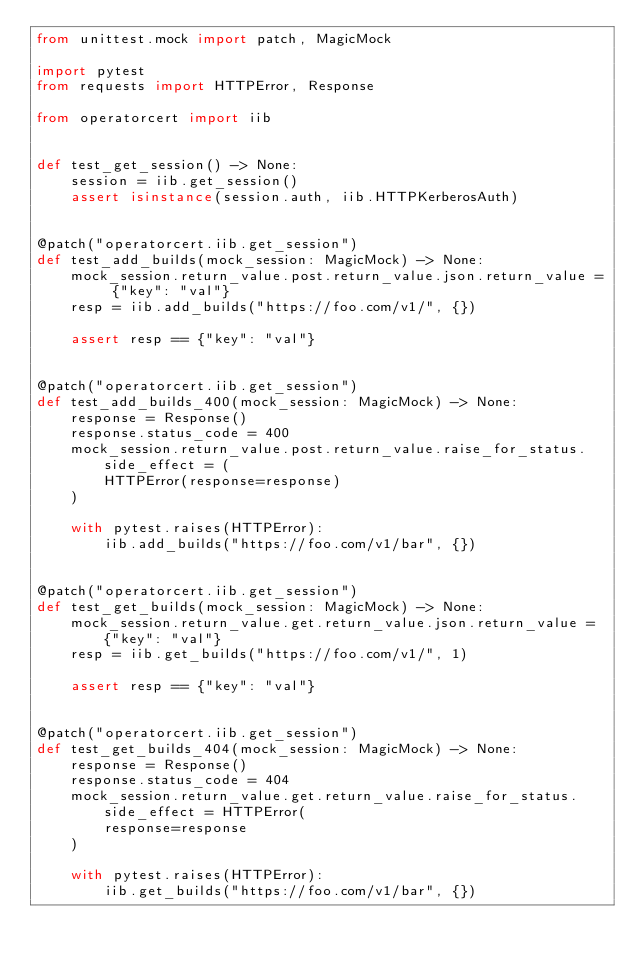<code> <loc_0><loc_0><loc_500><loc_500><_Python_>from unittest.mock import patch, MagicMock

import pytest
from requests import HTTPError, Response

from operatorcert import iib


def test_get_session() -> None:
    session = iib.get_session()
    assert isinstance(session.auth, iib.HTTPKerberosAuth)


@patch("operatorcert.iib.get_session")
def test_add_builds(mock_session: MagicMock) -> None:
    mock_session.return_value.post.return_value.json.return_value = {"key": "val"}
    resp = iib.add_builds("https://foo.com/v1/", {})

    assert resp == {"key": "val"}


@patch("operatorcert.iib.get_session")
def test_add_builds_400(mock_session: MagicMock) -> None:
    response = Response()
    response.status_code = 400
    mock_session.return_value.post.return_value.raise_for_status.side_effect = (
        HTTPError(response=response)
    )

    with pytest.raises(HTTPError):
        iib.add_builds("https://foo.com/v1/bar", {})


@patch("operatorcert.iib.get_session")
def test_get_builds(mock_session: MagicMock) -> None:
    mock_session.return_value.get.return_value.json.return_value = {"key": "val"}
    resp = iib.get_builds("https://foo.com/v1/", 1)

    assert resp == {"key": "val"}


@patch("operatorcert.iib.get_session")
def test_get_builds_404(mock_session: MagicMock) -> None:
    response = Response()
    response.status_code = 404
    mock_session.return_value.get.return_value.raise_for_status.side_effect = HTTPError(
        response=response
    )

    with pytest.raises(HTTPError):
        iib.get_builds("https://foo.com/v1/bar", {})
</code> 